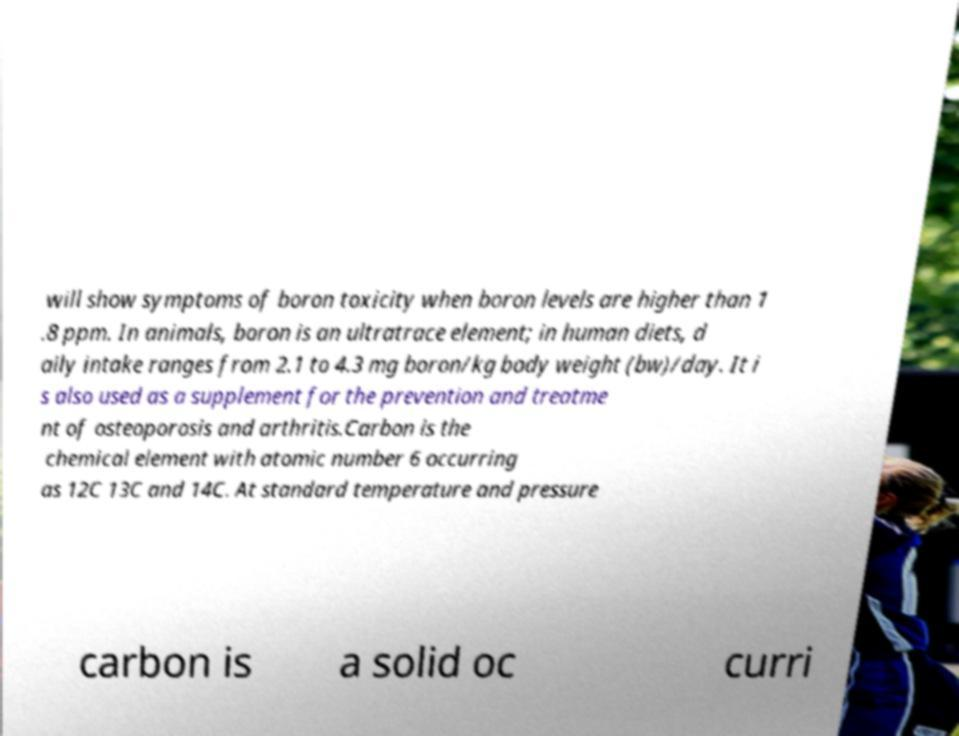There's text embedded in this image that I need extracted. Can you transcribe it verbatim? will show symptoms of boron toxicity when boron levels are higher than 1 .8 ppm. In animals, boron is an ultratrace element; in human diets, d aily intake ranges from 2.1 to 4.3 mg boron/kg body weight (bw)/day. It i s also used as a supplement for the prevention and treatme nt of osteoporosis and arthritis.Carbon is the chemical element with atomic number 6 occurring as 12C 13C and 14C. At standard temperature and pressure carbon is a solid oc curri 